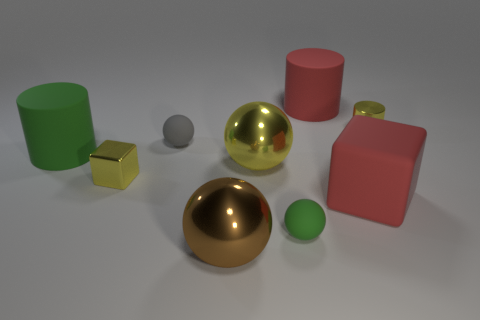Subtract all gray balls. How many balls are left? 3 Subtract all balls. How many objects are left? 5 Add 7 cylinders. How many cylinders exist? 10 Subtract all green cylinders. How many cylinders are left? 2 Subtract 1 brown spheres. How many objects are left? 8 Subtract 1 cubes. How many cubes are left? 1 Subtract all red balls. Subtract all blue cubes. How many balls are left? 4 Subtract all red blocks. How many yellow cylinders are left? 1 Subtract all big purple things. Subtract all big cylinders. How many objects are left? 7 Add 9 small gray balls. How many small gray balls are left? 10 